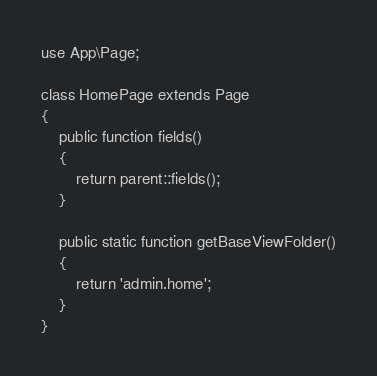Convert code to text. <code><loc_0><loc_0><loc_500><loc_500><_PHP_>
use App\Page;

class HomePage extends Page
{
    public function fields()
    {
        return parent::fields();
    }

    public static function getBaseViewFolder()
    {
        return 'admin.home';
    }
}
</code> 